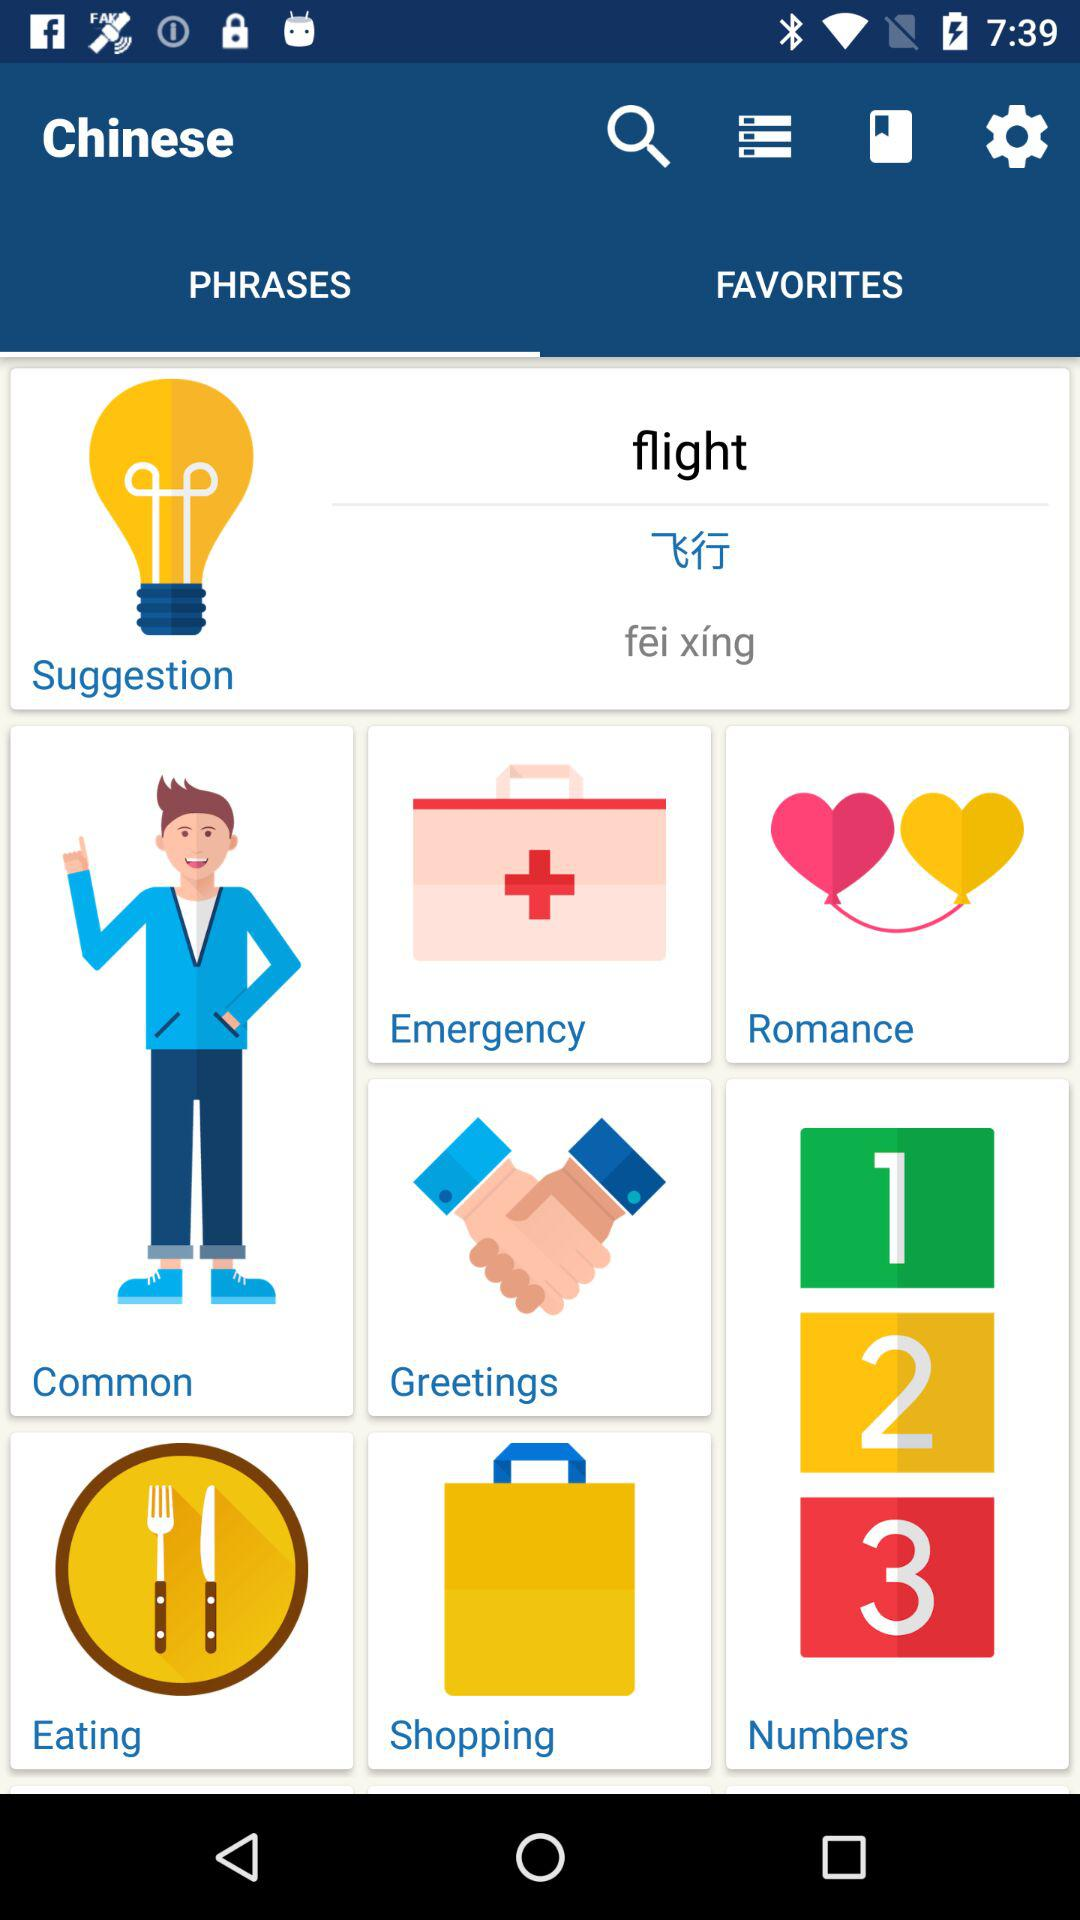How many categories are there on this page?
Answer the question using a single word or phrase. 8 